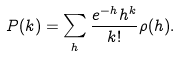Convert formula to latex. <formula><loc_0><loc_0><loc_500><loc_500>P ( k ) = \sum _ { h } \frac { e ^ { - h } h ^ { k } } { k ! } \rho ( h ) .</formula> 